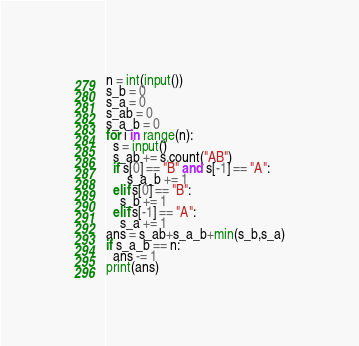<code> <loc_0><loc_0><loc_500><loc_500><_Python_>n = int(input())
s_b = 0
s_a = 0
s_ab = 0
s_a_b = 0
for i in range(n):
  s = input()
  s_ab += s.count("AB")
  if s[0] == "B" and s[-1] == "A":
      s_a_b += 1
  elif s[0] == "B":
    s_b += 1
  elif s[-1] == "A":
    s_a += 1
ans = s_ab+s_a_b+min(s_b,s_a)
if s_a_b == n:
  ans -= 1
print(ans)
</code> 